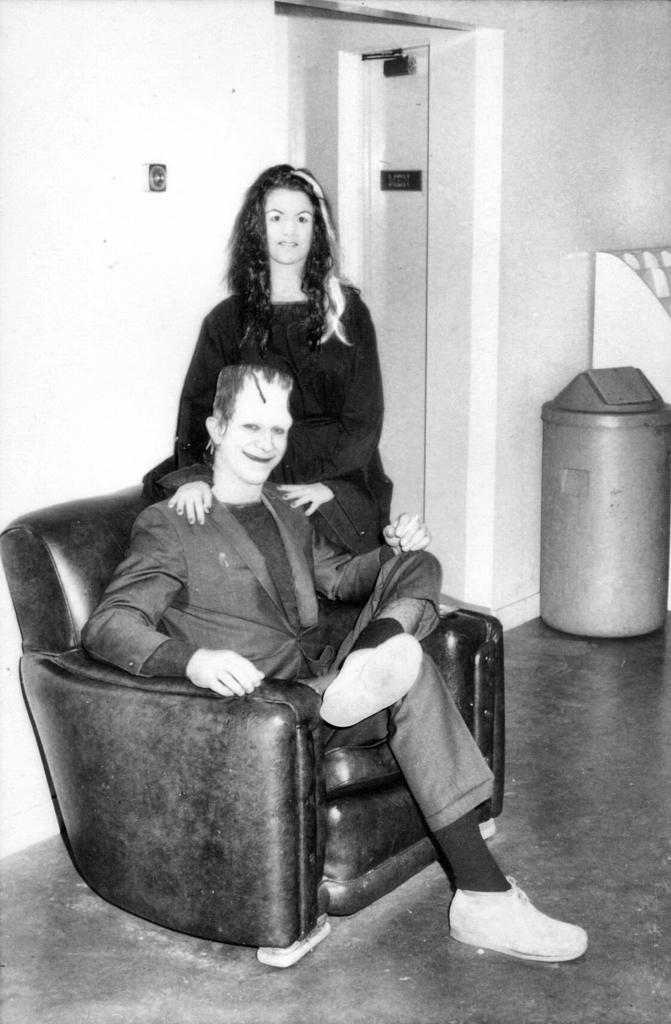In one or two sentences, can you explain what this image depicts? In the center we can see the two persons one of the man he is sitting on the sofa and lady she is standing. coming to the background there is a wall. 